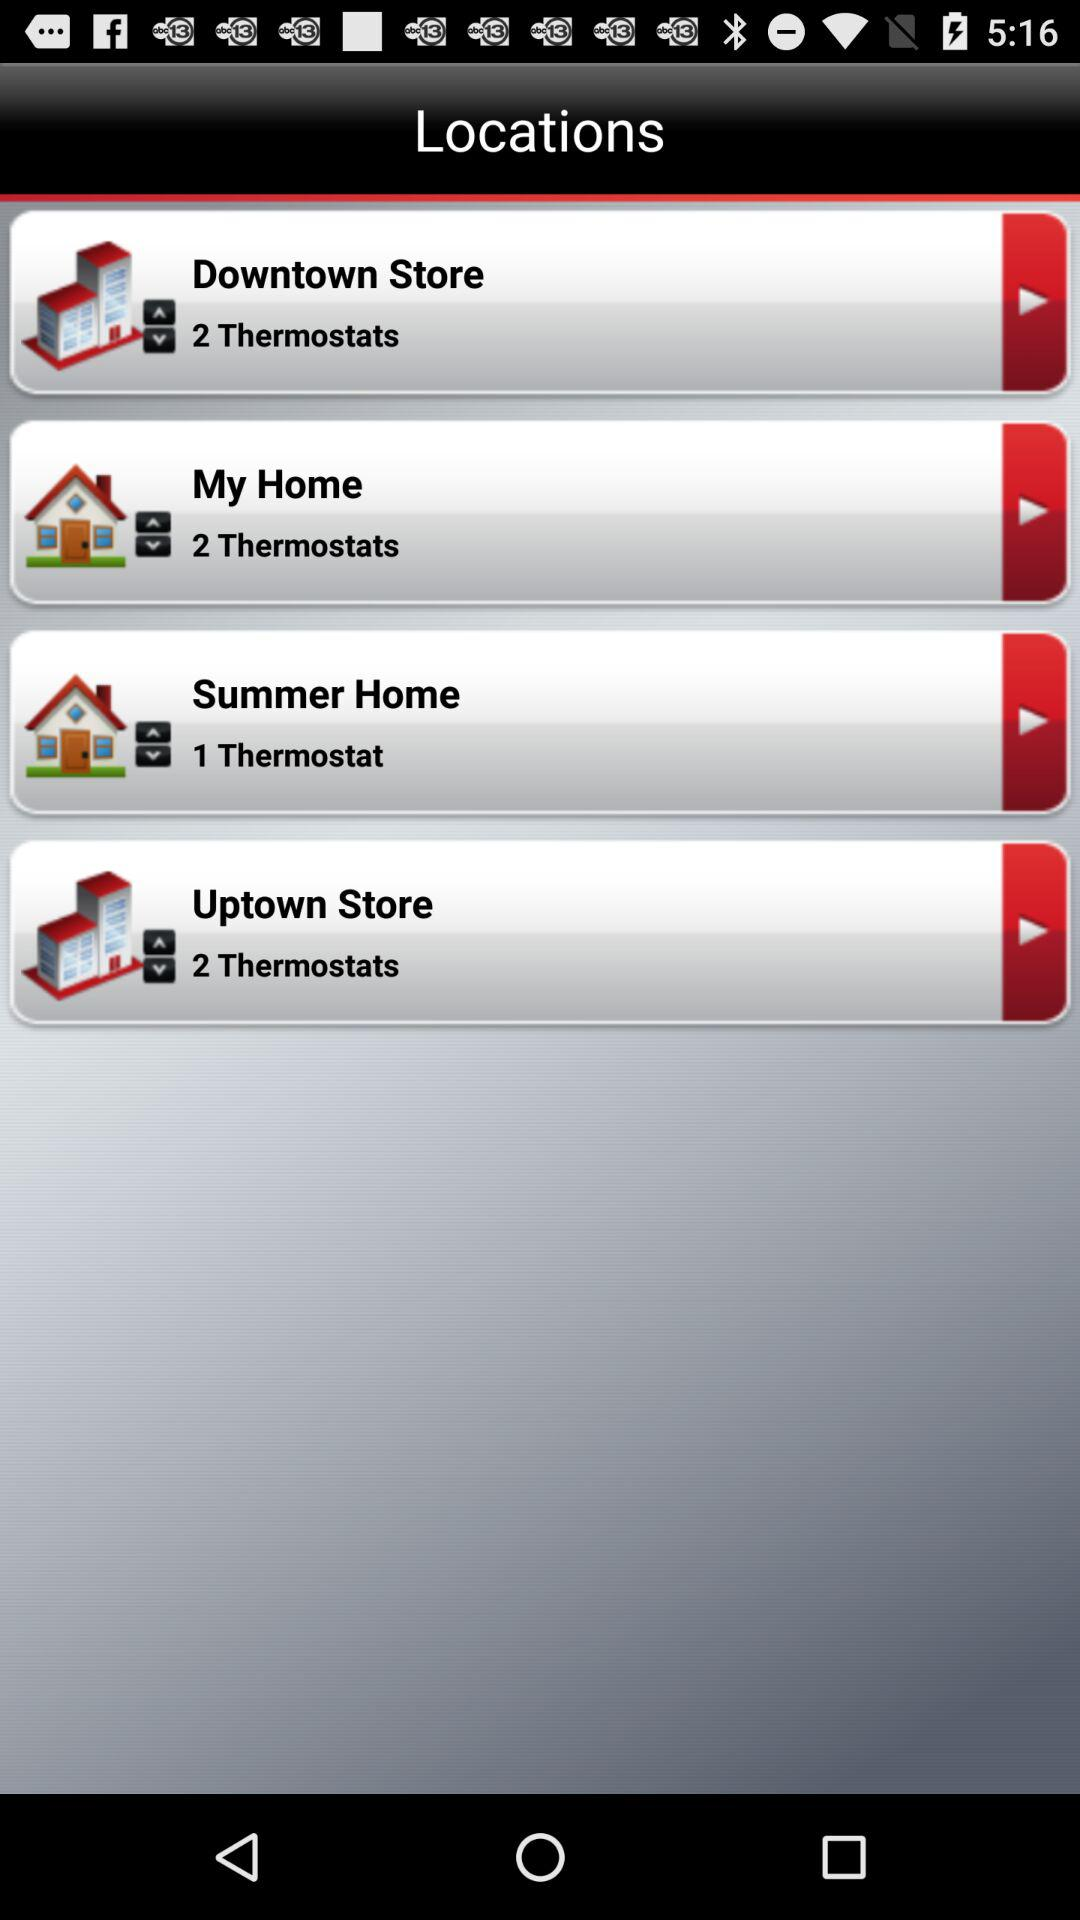Summer Home situated at which thermostat? It is situated at 1 thermostat. 